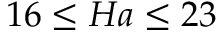Convert formula to latex. <formula><loc_0><loc_0><loc_500><loc_500>1 6 \leq H a \leq 2 3</formula> 